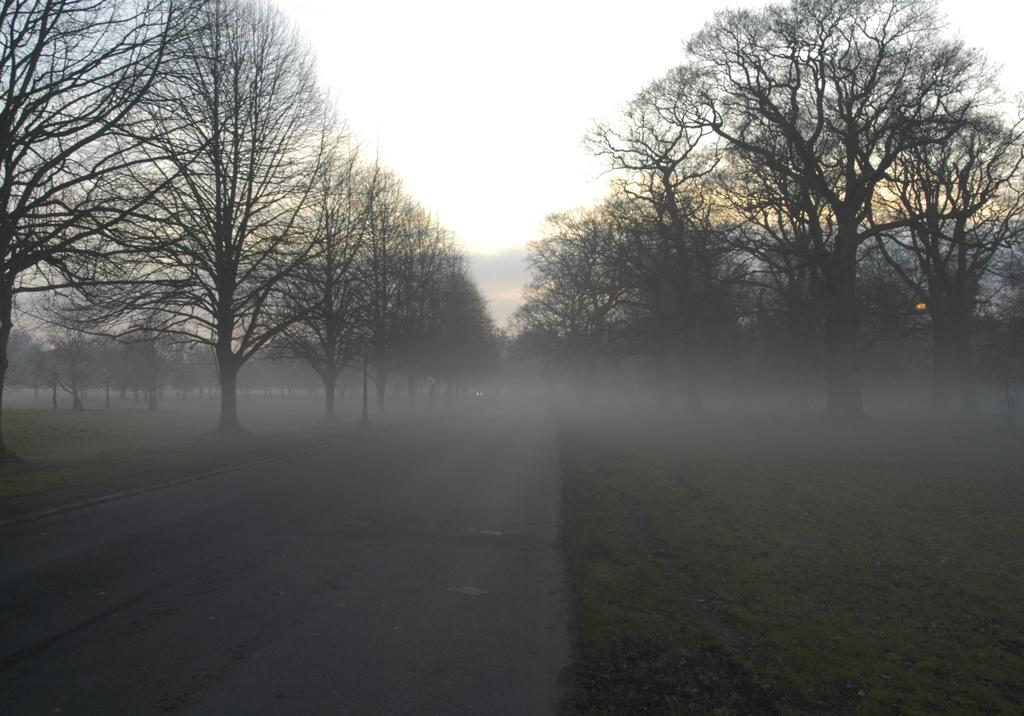What type of vegetation is visible in the image? There are trees in the image. What is the weather like in the image? There is snow visible in the image, suggesting a cold or snowy environment. What part of the natural environment is visible in the image? The sky is visible in the image. Can you tell me how many years ago the crime took place in the image? There is no reference to a crime or any specific time period in the image, so it is not possible to answer that question. 